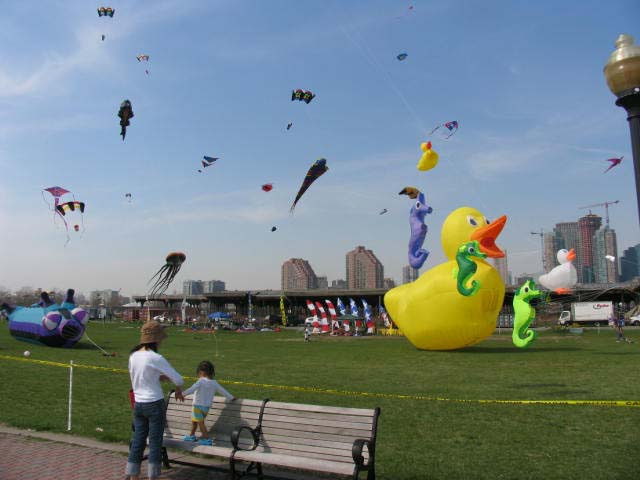<image>Why did they paint it yellow? It is ambiguous why they painted it yellow. It might be because rubber ducks are traditionally yellow. Why did they paint it yellow? I don't know why they painted it yellow. It could be for different reasons such as tradition, to see it better, or simply because ducks are usually yellow. 